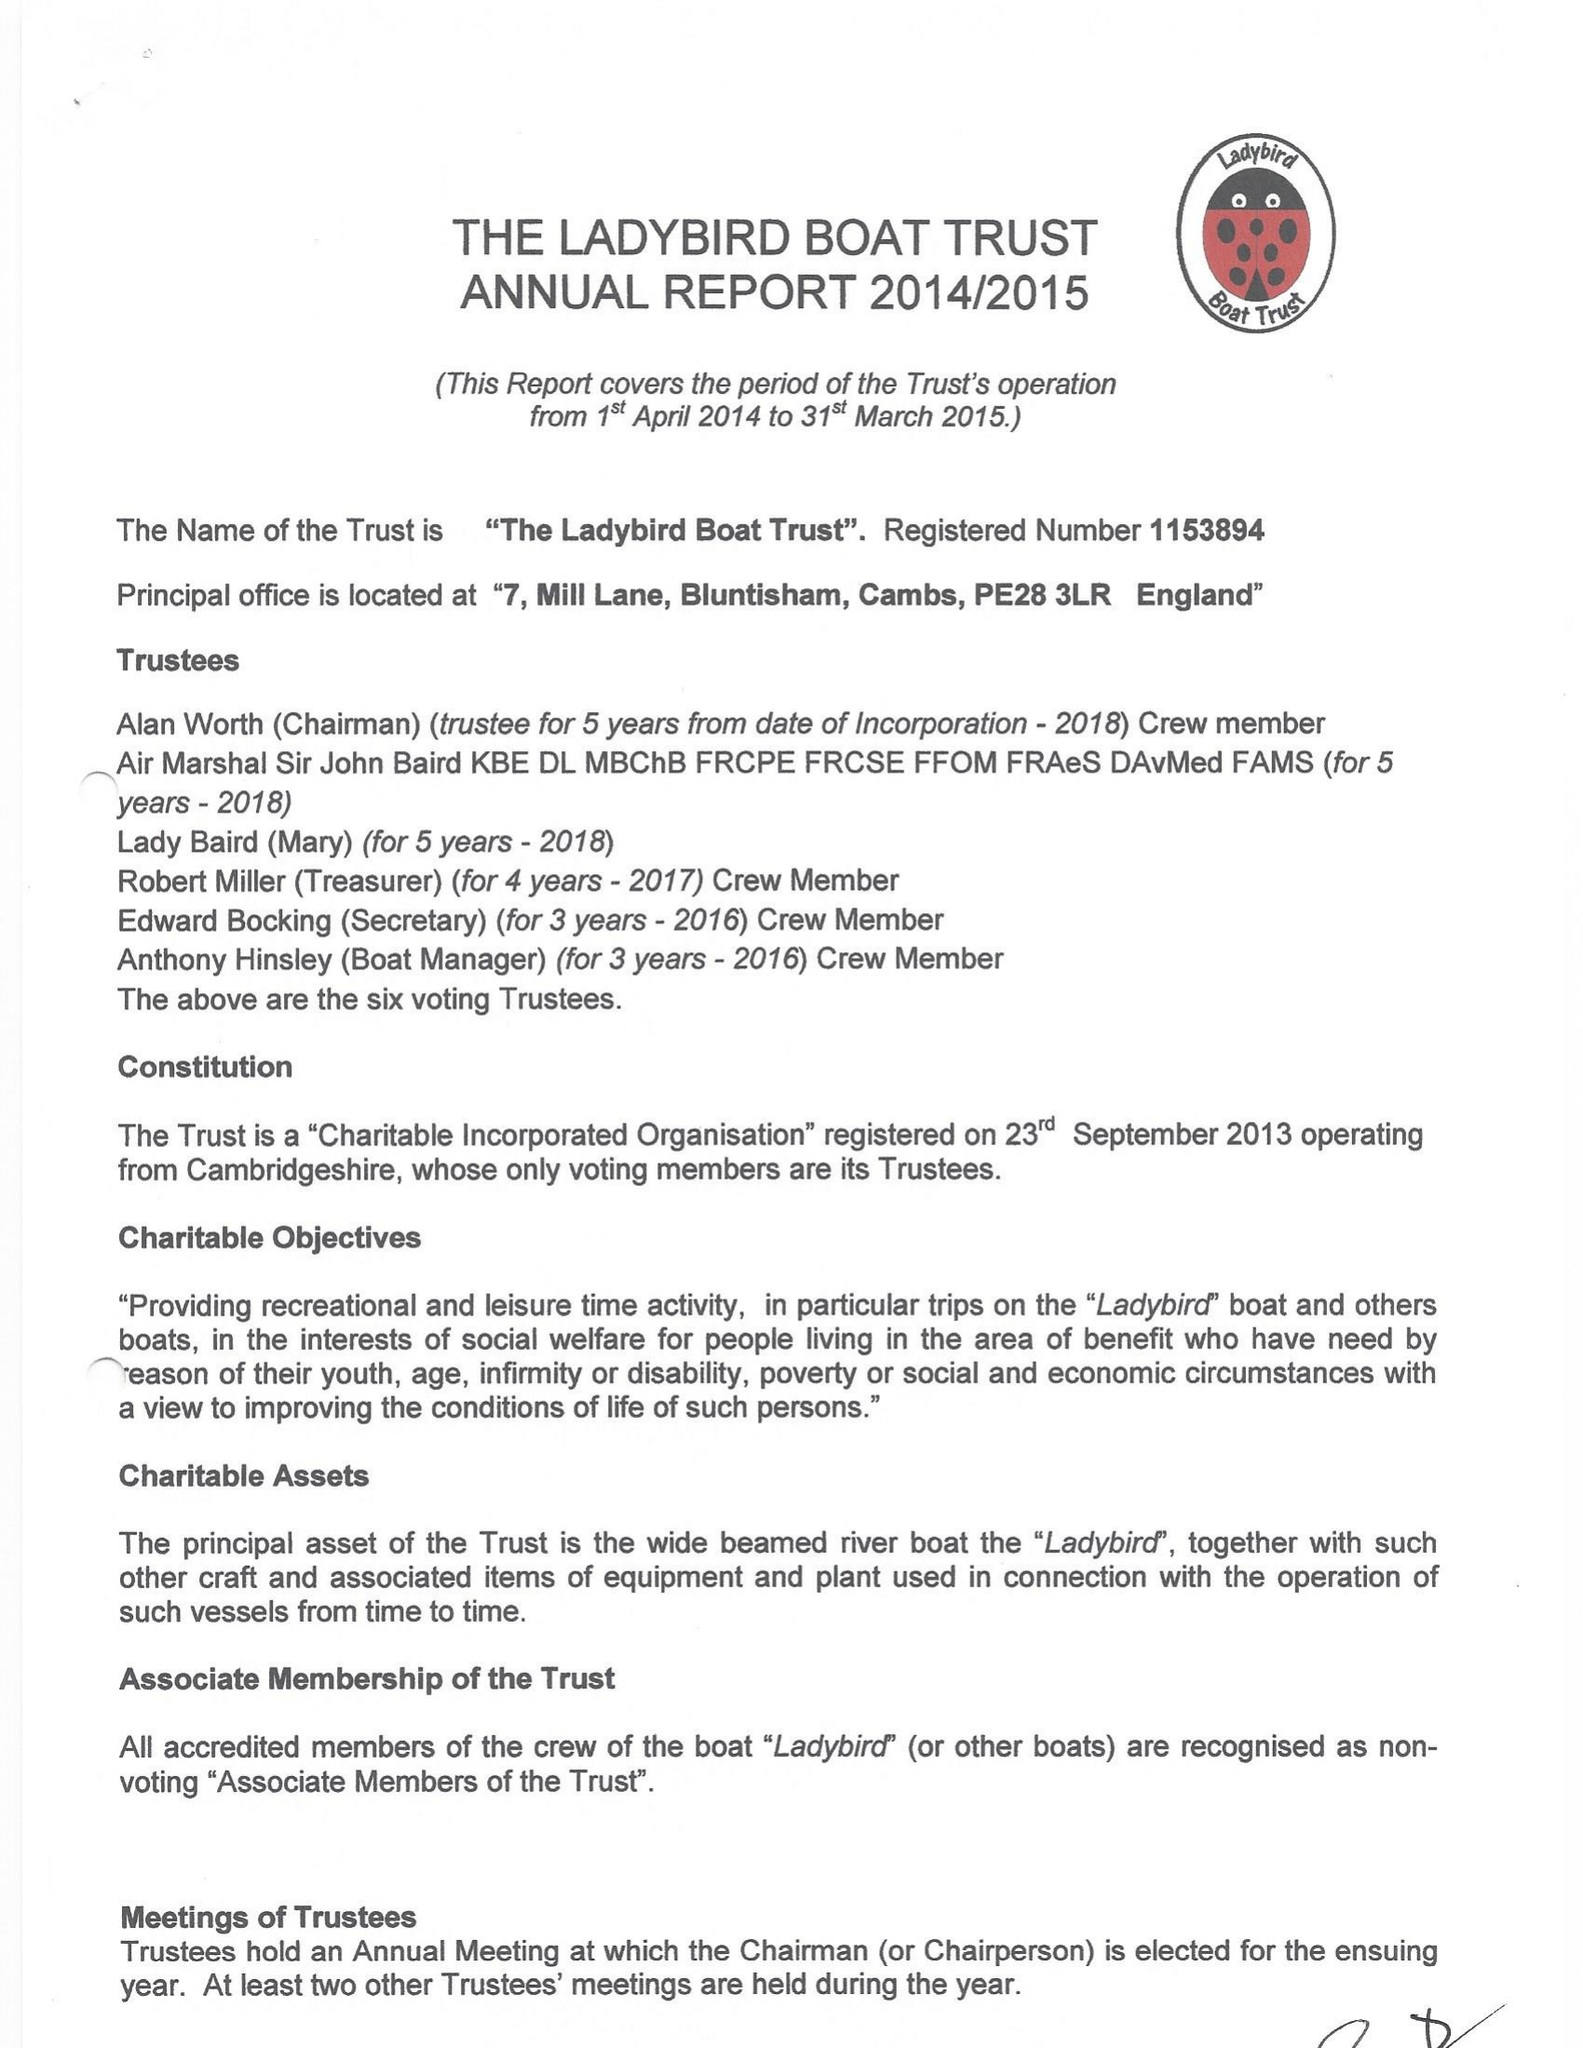What is the value for the address__postcode?
Answer the question using a single word or phrase. PE29 3RB 